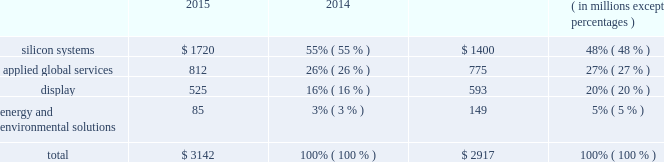Backlog applied manufactures systems to meet demand represented by order backlog and customer commitments .
Backlog consists of : ( 1 ) orders for which written authorizations have been accepted and assigned shipment dates are within the next 12 months , or shipment has occurred but revenue has not been recognized ; and ( 2 ) contractual service revenue and maintenance fees to be earned within the next 12 months .
Backlog by reportable segment as of october 25 , 2015 and october 26 , 2014 was as follows : 2015 2014 ( in millions , except percentages ) .
Applied 2019s backlog on any particular date is not necessarily indicative of actual sales for any future periods , due to the potential for customer changes in delivery schedules or order cancellations .
Customers may delay delivery of products or cancel orders prior to shipment , subject to possible cancellation penalties .
Delays in delivery schedules or a reduction of backlog during any particular period could have a material adverse effect on applied 2019s business and results of operations .
Manufacturing , raw materials and supplies applied 2019s manufacturing activities consist primarily of assembly , test and integration of various proprietary and commercial parts , components and subassemblies that are used to manufacture systems .
Applied has implemented a distributed manufacturing model under which manufacturing and supply chain activities are conducted in various countries , including germany , israel , italy , singapore , taiwan , the united states and other countries in asia .
Applied uses numerous vendors , including contract manufacturers , to supply parts and assembly services for the manufacture and support of its products , including some systems being completed at customer sites .
Although applied makes reasonable efforts to assure that parts are available from multiple qualified suppliers , this is not always possible .
Accordingly , some key parts may be obtained from only a single supplier or a limited group of suppliers .
Applied seeks to reduce costs and to lower the risks of manufacturing and service interruptions by selecting and qualifying alternate suppliers for key parts ; monitoring the financial condition of key suppliers ; maintaining appropriate inventories of key parts ; qualifying new parts on a timely basis ; and ensuring quality and performance of parts. .
How much percentage has backlog increased from 2014 to 2015? 
Rationale: the backlog has increased 7.7% from 2014 to 2015 , this is calculated by taking subtracting the totals from the two years and dividing the solution by 2014 backlog total .
Computations: ((3142 - 2917) / 2917)
Answer: 0.07713. 